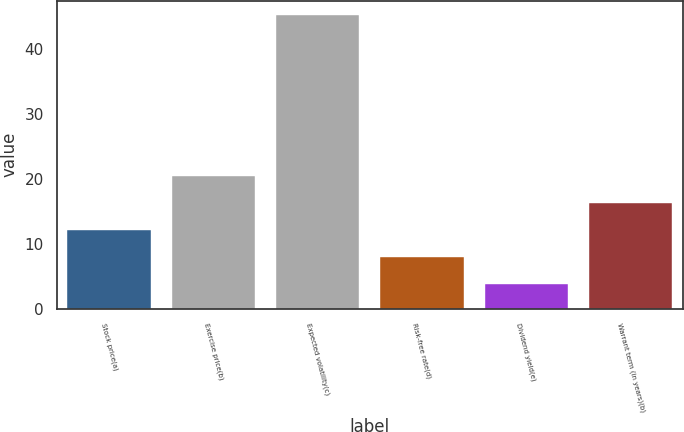<chart> <loc_0><loc_0><loc_500><loc_500><bar_chart><fcel>Stock price(a)<fcel>Exercise price(b)<fcel>Expected volatility(c)<fcel>Risk-free rate(d)<fcel>Dividend yield(e)<fcel>Warrant term (in years)(b)<nl><fcel>12.14<fcel>20.4<fcel>45.22<fcel>8.01<fcel>3.88<fcel>16.27<nl></chart> 